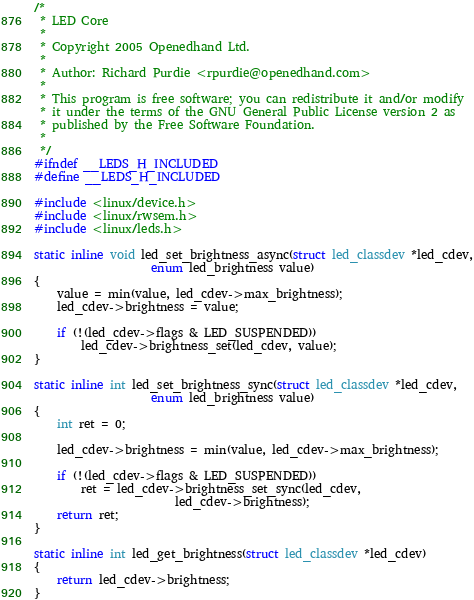Convert code to text. <code><loc_0><loc_0><loc_500><loc_500><_C_>/*
 * LED Core
 *
 * Copyright 2005 Openedhand Ltd.
 *
 * Author: Richard Purdie <rpurdie@openedhand.com>
 *
 * This program is free software; you can redistribute it and/or modify
 * it under the terms of the GNU General Public License version 2 as
 * published by the Free Software Foundation.
 *
 */
#ifndef __LEDS_H_INCLUDED
#define __LEDS_H_INCLUDED

#include <linux/device.h>
#include <linux/rwsem.h>
#include <linux/leds.h>

static inline void led_set_brightness_async(struct led_classdev *led_cdev,
					enum led_brightness value)
{
	value = min(value, led_cdev->max_brightness);
	led_cdev->brightness = value;

	if (!(led_cdev->flags & LED_SUSPENDED))
		led_cdev->brightness_set(led_cdev, value);
}

static inline int led_set_brightness_sync(struct led_classdev *led_cdev,
					enum led_brightness value)
{
	int ret = 0;

	led_cdev->brightness = min(value, led_cdev->max_brightness);

	if (!(led_cdev->flags & LED_SUSPENDED))
		ret = led_cdev->brightness_set_sync(led_cdev,
						led_cdev->brightness);
	return ret;
}

static inline int led_get_brightness(struct led_classdev *led_cdev)
{
	return led_cdev->brightness;
}
</code> 